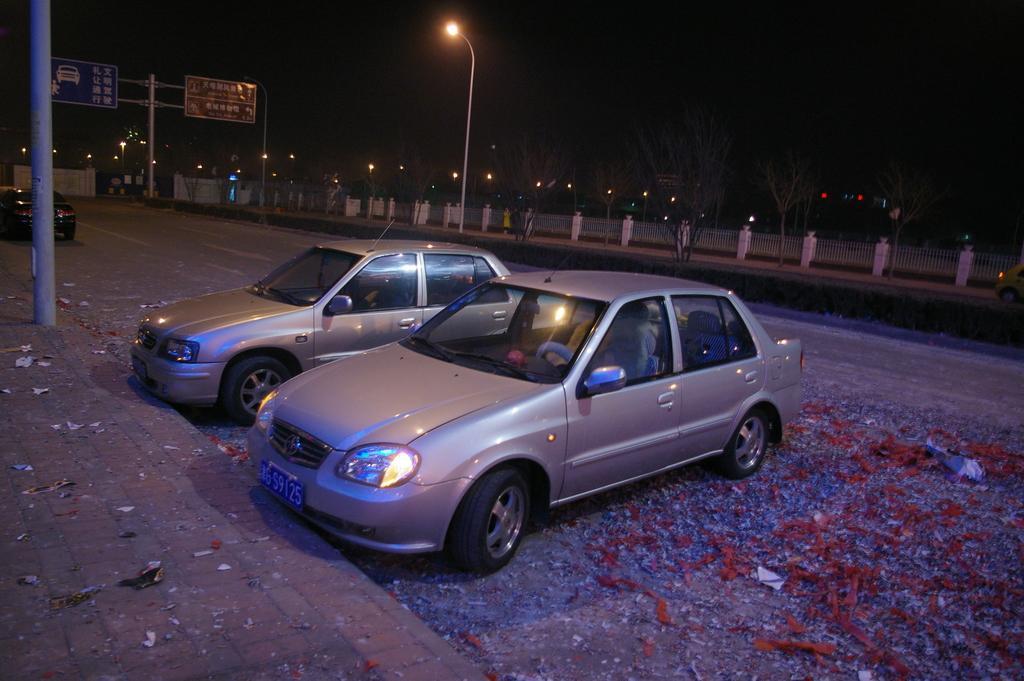Could you give a brief overview of what you see in this image? In the picture we can see a path with a poll on it and besides, we can see two cars parked and in the background, we can see a road and path and street light to the pole and behind it we can see a railing and some lights far away in the dark. 